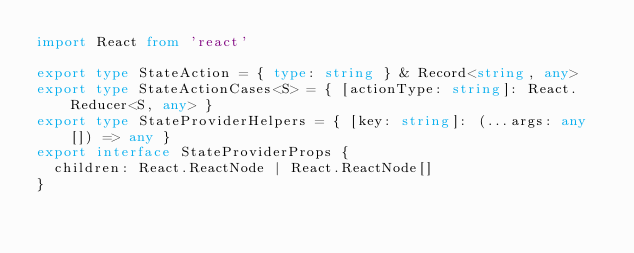Convert code to text. <code><loc_0><loc_0><loc_500><loc_500><_TypeScript_>import React from 'react'

export type StateAction = { type: string } & Record<string, any>
export type StateActionCases<S> = { [actionType: string]: React.Reducer<S, any> }
export type StateProviderHelpers = { [key: string]: (...args: any[]) => any }
export interface StateProviderProps {
  children: React.ReactNode | React.ReactNode[]
}
</code> 